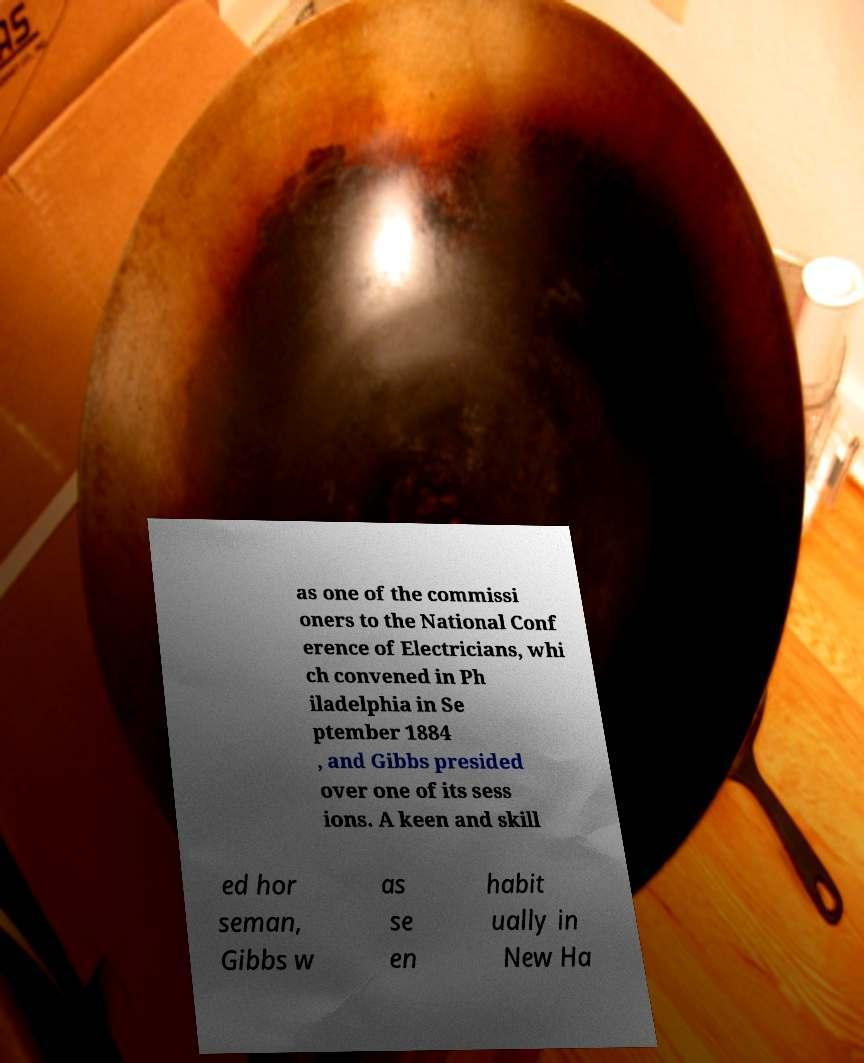Could you assist in decoding the text presented in this image and type it out clearly? as one of the commissi oners to the National Conf erence of Electricians, whi ch convened in Ph iladelphia in Se ptember 1884 , and Gibbs presided over one of its sess ions. A keen and skill ed hor seman, Gibbs w as se en habit ually in New Ha 